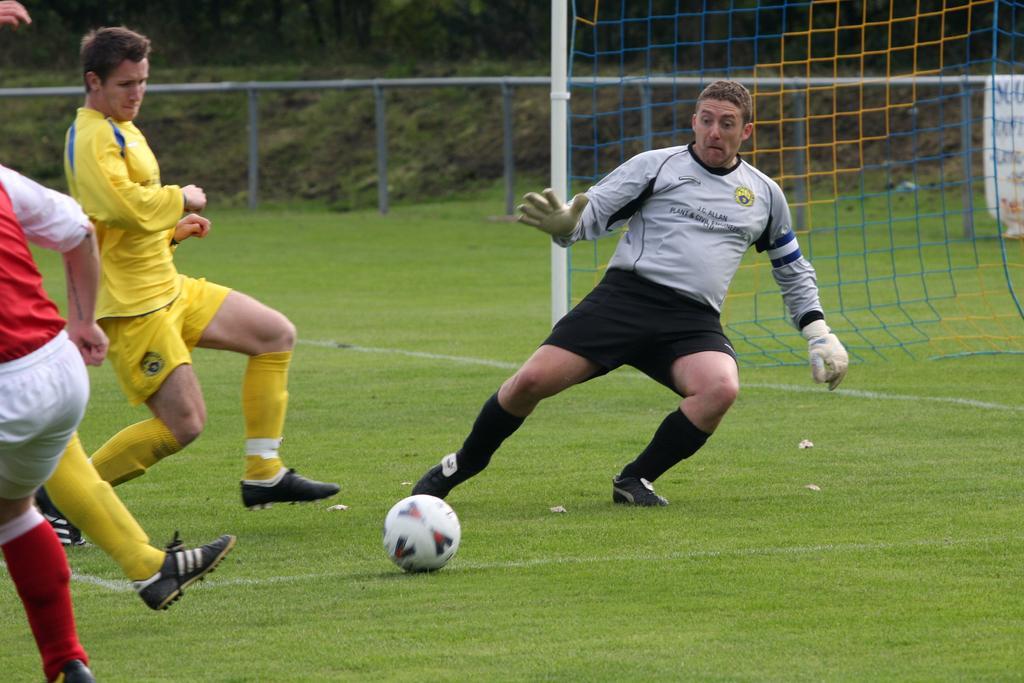How would you summarize this image in a sentence or two? In this picture two people are playing football and the goalkeeper is trying to stop it. In the background we observe a goal post and a fence. 